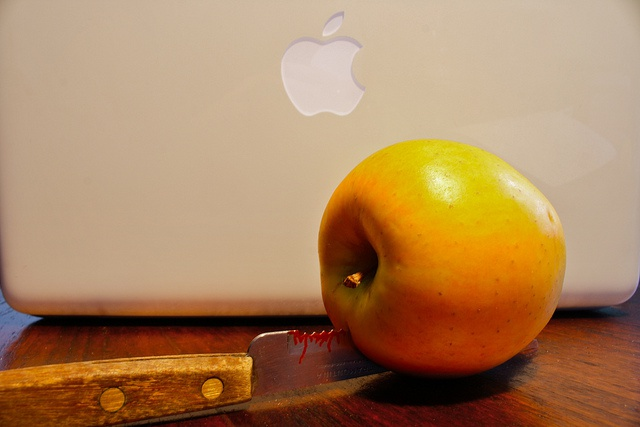Describe the objects in this image and their specific colors. I can see laptop in tan and lightgray tones, apple in tan, orange, and maroon tones, dining table in tan, brown, black, and maroon tones, knife in tan, maroon, brown, and orange tones, and dining table in tan, maroon, black, and gray tones in this image. 